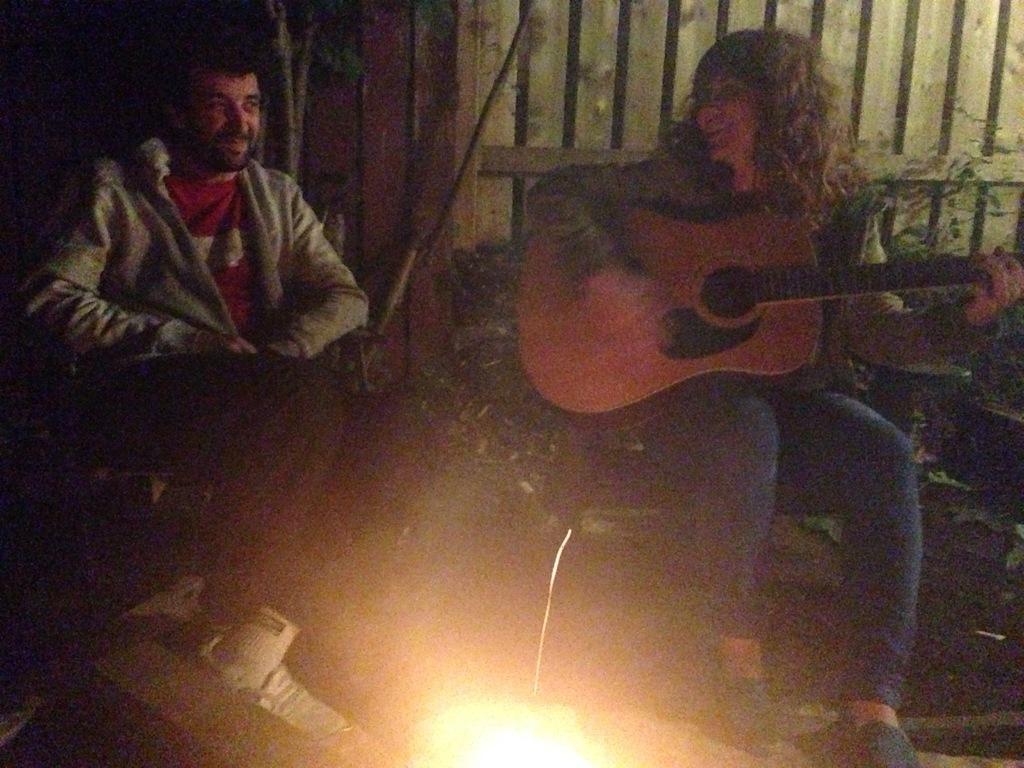Could you give a brief overview of what you see in this image? In this picture there is a woman sitting and playing guitar and there is a man sitting. In the foreground it looks like fire. At the back there is a wooden railing and there are plants. 